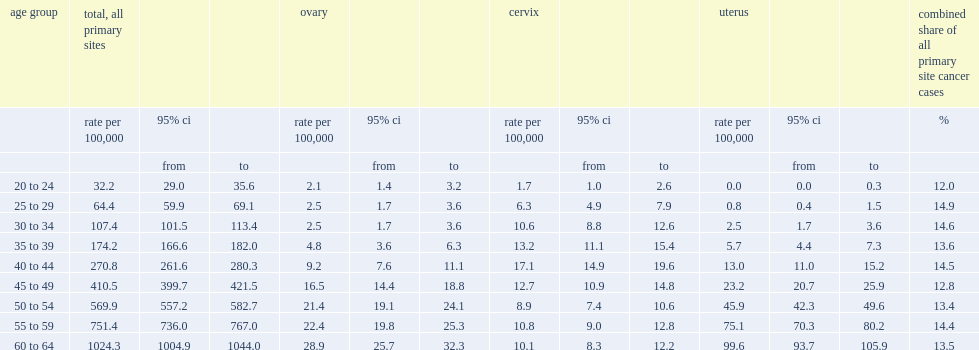What was the average percentage of these three cancers accounted for all new cancer cases in 2012 among women aged 20 to 64? 13.744444. 